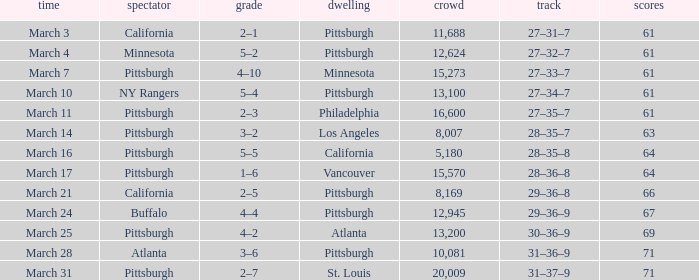What is the Score of the game with a Record of 31–37–9? 2–7. 